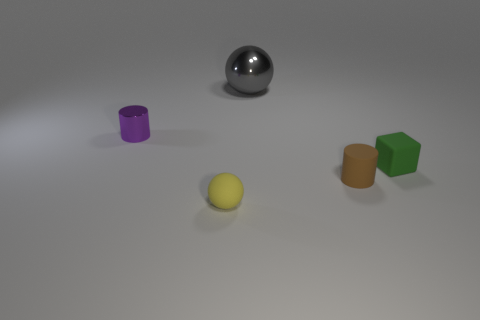Add 1 purple metal cylinders. How many objects exist? 6 Subtract all balls. How many objects are left? 3 Add 2 tiny gray cylinders. How many tiny gray cylinders exist? 2 Subtract 0 green cylinders. How many objects are left? 5 Subtract all big yellow shiny things. Subtract all shiny things. How many objects are left? 3 Add 5 tiny yellow rubber objects. How many tiny yellow rubber objects are left? 6 